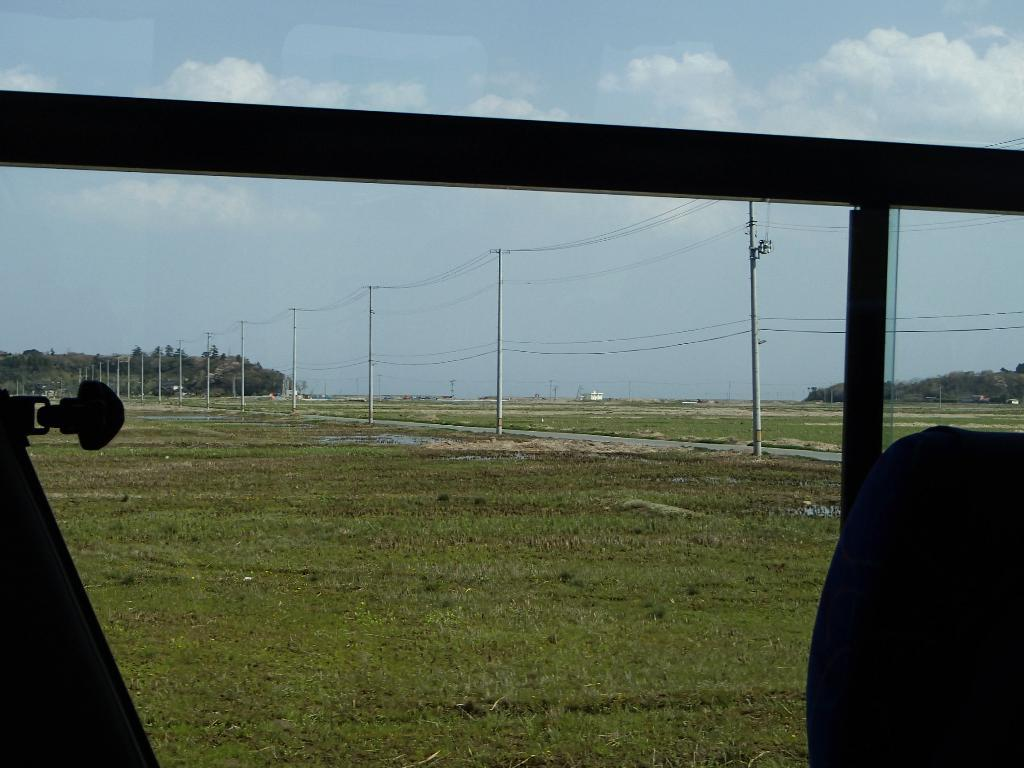What type of vegetation is on the ground in the image? There is grass on the ground in the image. What is attached to the pole in the image? There is a rod attached to the pole in the image. What can be seen in the background of the image? There are poles with wires and trees in the background, as well as the sky. What is visible in the sky in the image? Clouds are present in the sky in the image. Can you see a tramp in the image? There is no tramp present in the image. What type of root is growing on the pole with the rod? There are no roots visible on the pole with the rod in the image. 